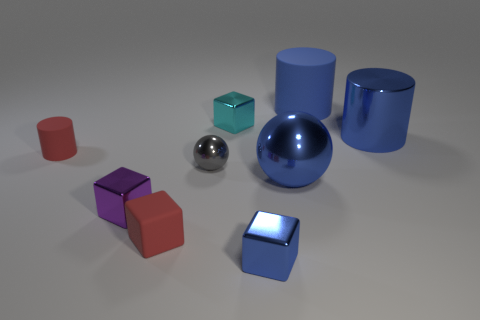How many other objects are the same color as the big rubber thing?
Give a very brief answer. 3. There is a shiny thing in front of the red block; is it the same size as the tiny red cylinder?
Keep it short and to the point. Yes. What is the material of the sphere that is to the left of the blue cube?
Keep it short and to the point. Metal. How many matte things are red blocks or purple balls?
Your answer should be compact. 1. Are there fewer big blue metal spheres behind the purple block than balls?
Provide a succinct answer. Yes. What shape is the rubber object that is in front of the gray object on the right side of the cylinder that is on the left side of the small blue shiny thing?
Make the answer very short. Cube. Is the big matte object the same color as the shiny cylinder?
Provide a short and direct response. Yes. Are there more small gray balls than cylinders?
Make the answer very short. No. What number of other things are there of the same material as the red block
Ensure brevity in your answer.  2. How many things are either gray cubes or objects that are left of the cyan shiny thing?
Provide a succinct answer. 4. 